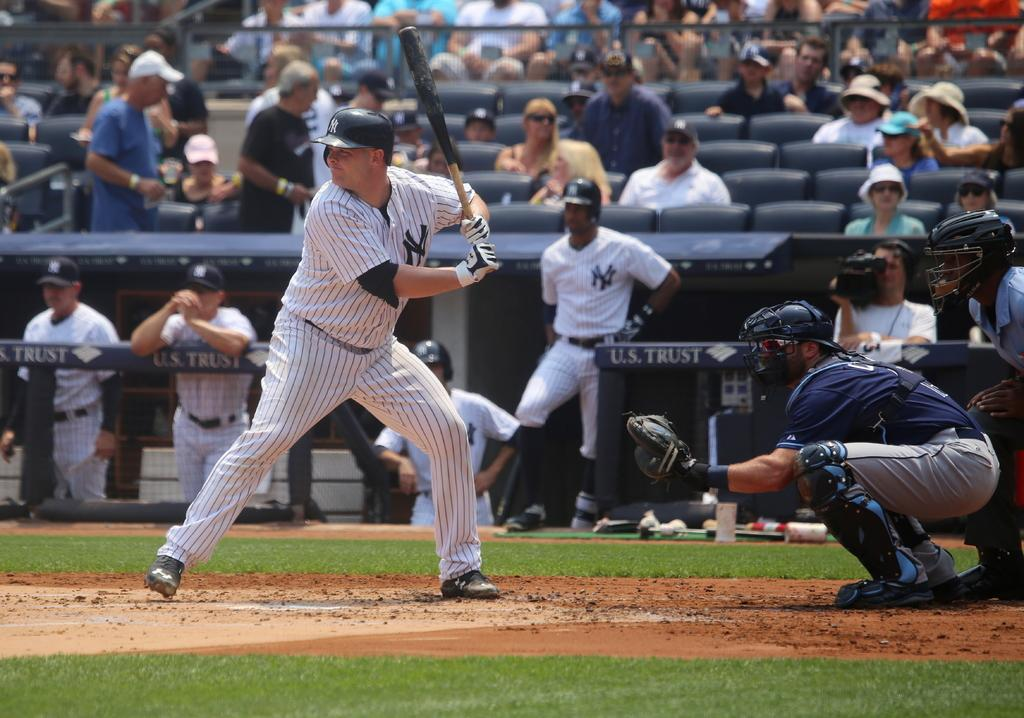<image>
Describe the image concisely. a new york yankees baseball game with the words 'U.S. TRUST' on the side lines 